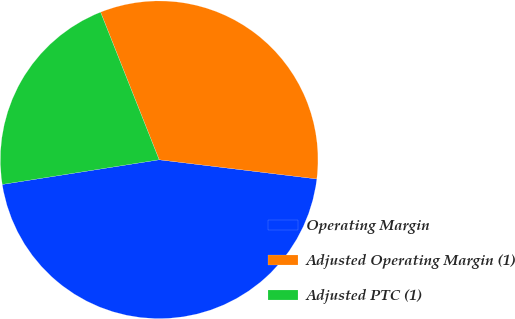Convert chart to OTSL. <chart><loc_0><loc_0><loc_500><loc_500><pie_chart><fcel>Operating Margin<fcel>Adjusted Operating Margin (1)<fcel>Adjusted PTC (1)<nl><fcel>45.59%<fcel>32.94%<fcel>21.47%<nl></chart> 